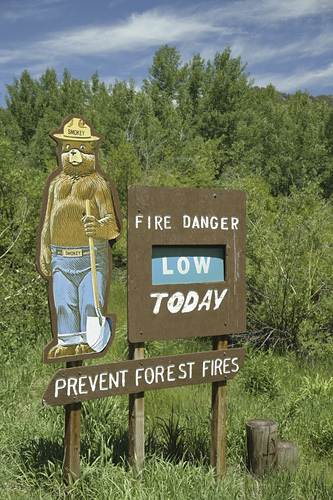<image>
Is the tree in front of the sign? No. The tree is not in front of the sign. The spatial positioning shows a different relationship between these objects. 